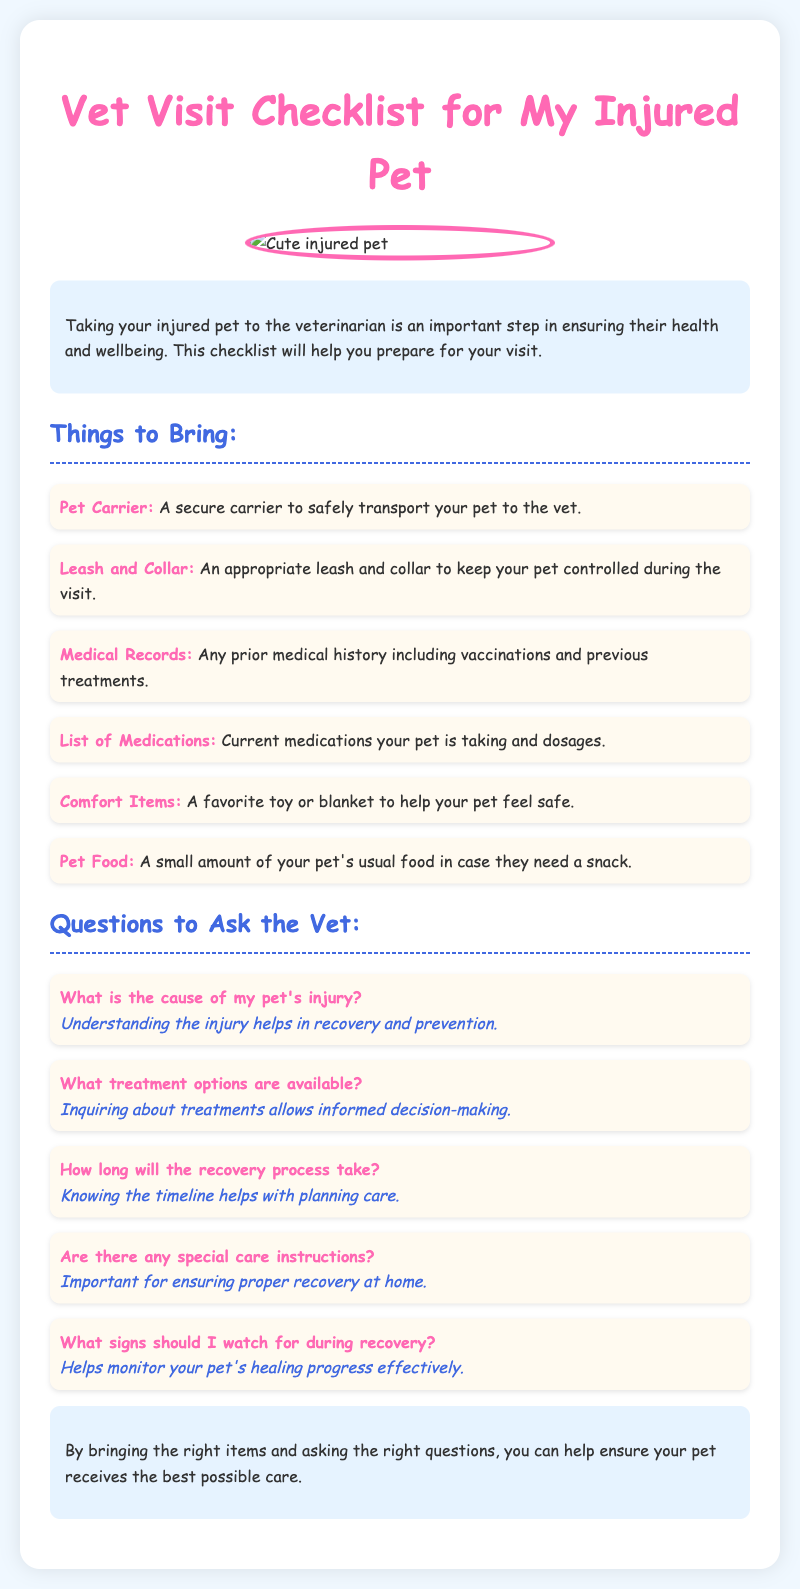What should I bring to the vet? The document provides a list of items to bring to the vet for an injured pet.
Answer: Pet Carrier, Leash and Collar, Medical Records, List of Medications, Comfort Items, Pet Food What is the importance of asking about treatment options? The document states that inquiring about treatments allows informed decision-making, which is important for pet care.
Answer: Informed decision-making What should I watch for during recovery? The document suggests asking the vet for specific signs to monitor during the pet's recovery process.
Answer: Signs of recovery What color is the title of the document? The title features a specific color that is highlighted in the document's style section.
Answer: Pink How many questions are listed to ask the vet? The document includes a specific number of questions directed at the veterinarian regarding pet care.
Answer: Five 